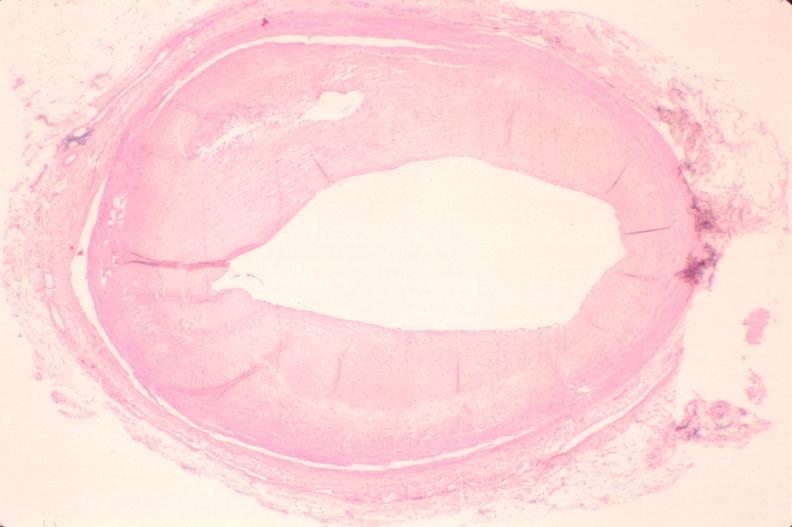s vasculature present?
Answer the question using a single word or phrase. Yes 